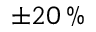<formula> <loc_0><loc_0><loc_500><loc_500>\pm 2 0 \, \%</formula> 